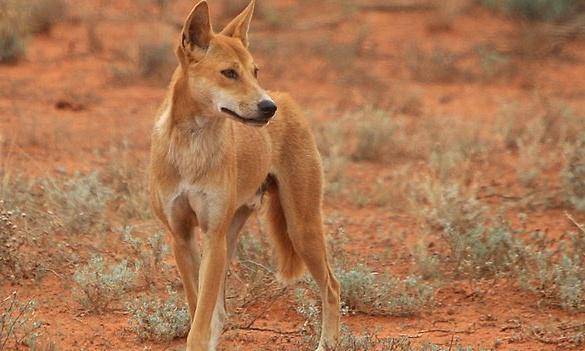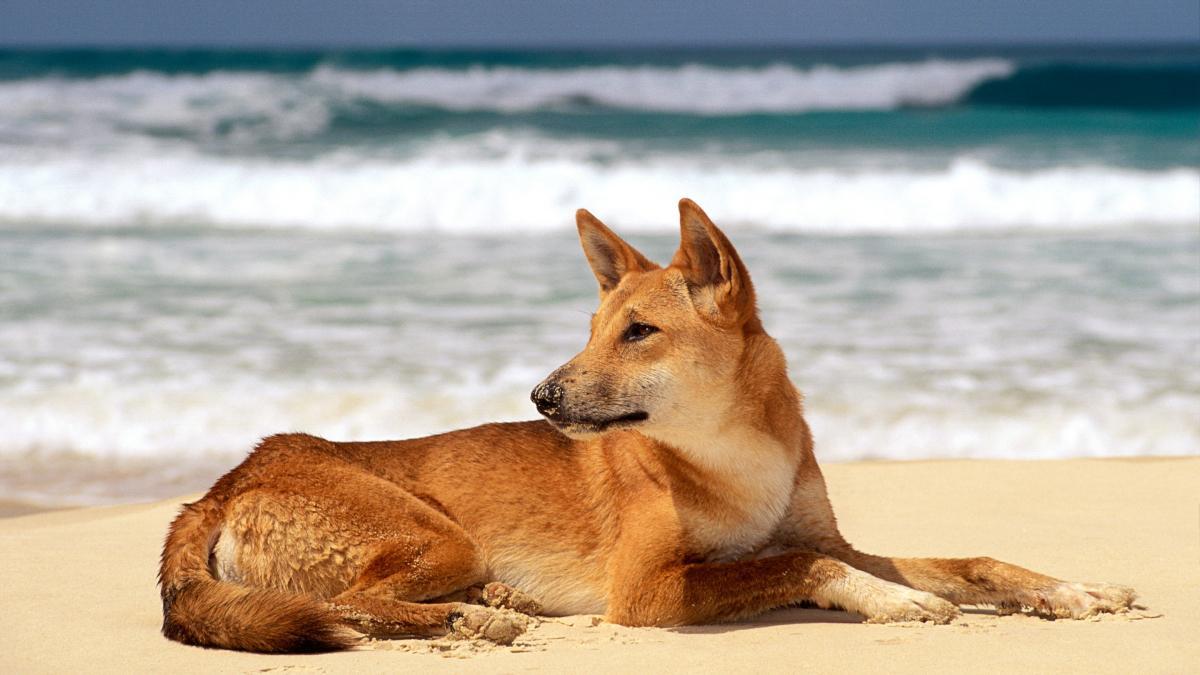The first image is the image on the left, the second image is the image on the right. Given the left and right images, does the statement "There are two dogs, and neither of them is looking to the left." hold true? Answer yes or no. No. The first image is the image on the left, the second image is the image on the right. Considering the images on both sides, is "The dog in the left image stands on a rock, body in profile turned rightward." valid? Answer yes or no. No. 